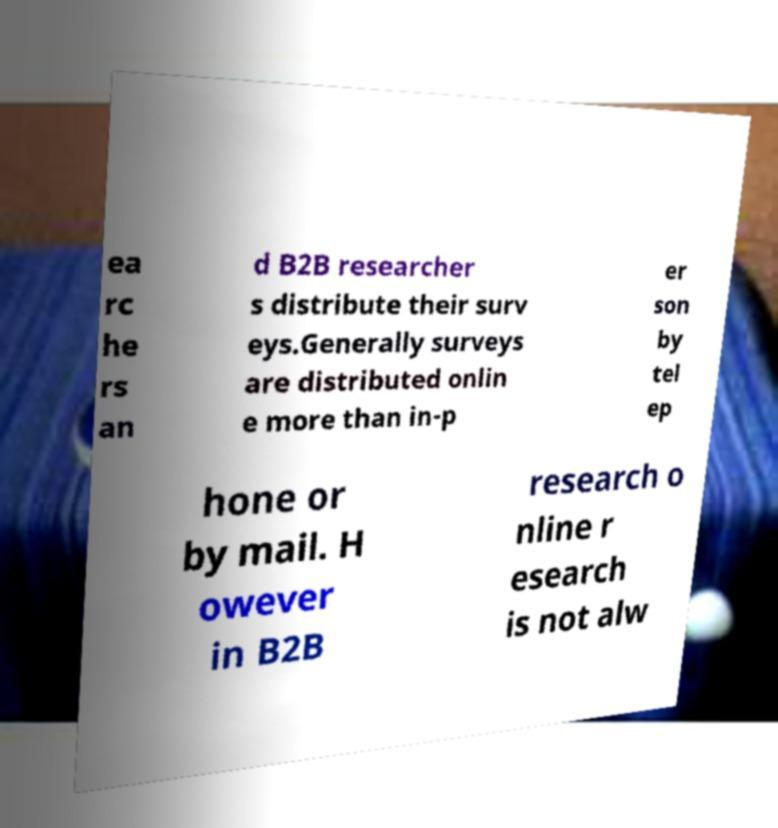What messages or text are displayed in this image? I need them in a readable, typed format. ea rc he rs an d B2B researcher s distribute their surv eys.Generally surveys are distributed onlin e more than in-p er son by tel ep hone or by mail. H owever in B2B research o nline r esearch is not alw 